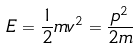Convert formula to latex. <formula><loc_0><loc_0><loc_500><loc_500>E = \frac { 1 } { 2 } m v ^ { 2 } = \frac { p ^ { 2 } } { 2 m }</formula> 